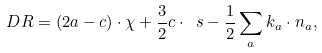<formula> <loc_0><loc_0><loc_500><loc_500>\ D R = ( 2 a - c ) \cdot \chi + \frac { 3 } { 2 } c \cdot \ s - \frac { 1 } { 2 } \sum _ { a } k _ { a } \cdot n _ { a } ,</formula> 